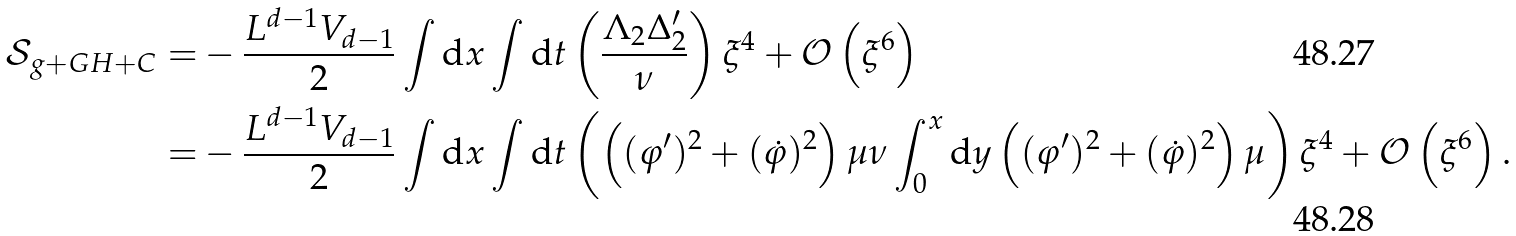Convert formula to latex. <formula><loc_0><loc_0><loc_500><loc_500>\mathcal { S } _ { g + G H + C } = & - \frac { L ^ { d - 1 } V _ { d - 1 } } { 2 } \int \text {d} x \int \text {d} t \left ( \frac { \Lambda _ { 2 } \Delta ^ { \prime } _ { 2 } } { \nu } \right ) \xi ^ { 4 } + \mathcal { O } \left ( \xi ^ { 6 } \right ) \\ = & - \frac { L ^ { d - 1 } V _ { d - 1 } } { 2 } \int \text {d} x \int \text {d} t \left ( \left ( ( \varphi ^ { \prime } ) ^ { 2 } + ( \dot { \varphi } ) ^ { 2 } \right ) \mu \nu \int _ { 0 } ^ { x } \text {d} y \left ( ( \varphi ^ { \prime } ) ^ { 2 } + ( \dot { \varphi } ) ^ { 2 } \right ) \mu \right ) \xi ^ { 4 } + \mathcal { O } \left ( \xi ^ { 6 } \right ) .</formula> 